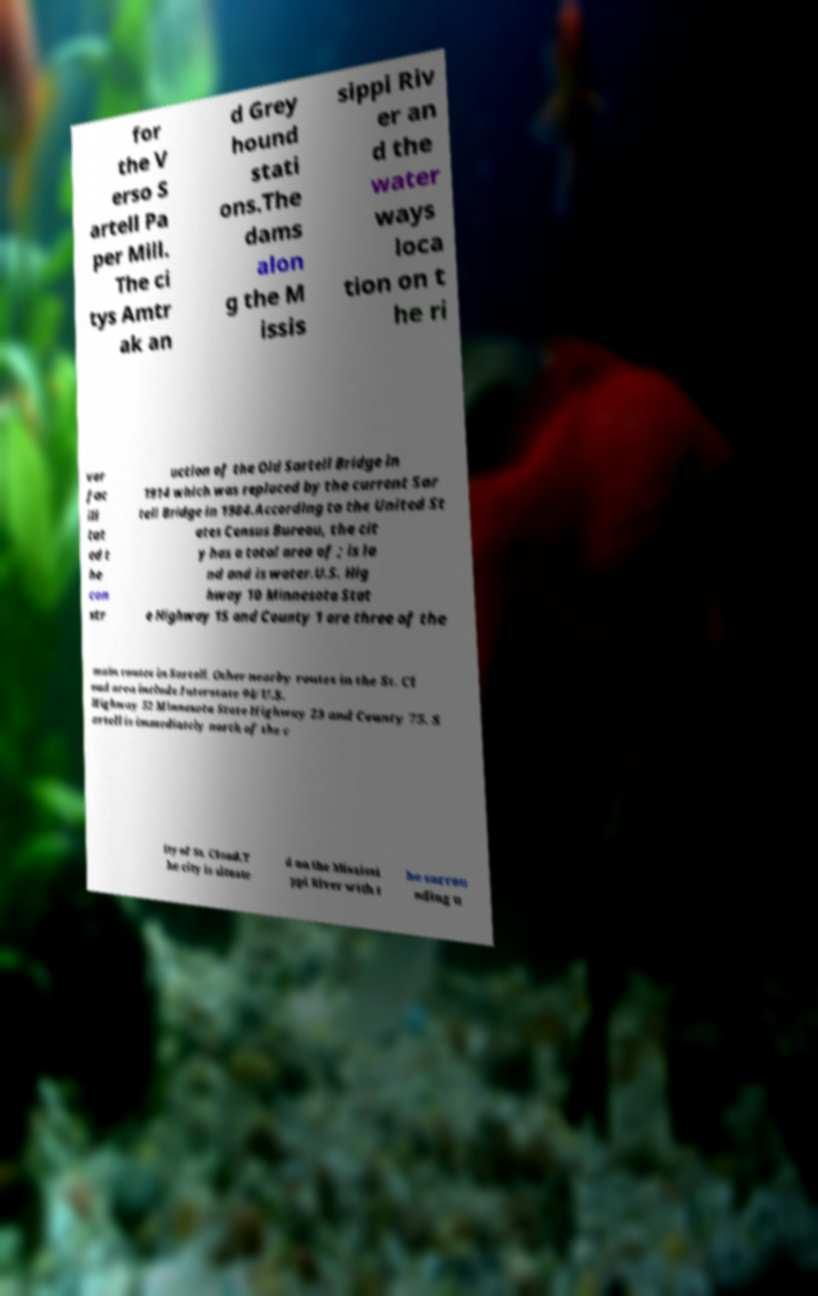Can you read and provide the text displayed in the image?This photo seems to have some interesting text. Can you extract and type it out for me? for the V erso S artell Pa per Mill. The ci tys Amtr ak an d Grey hound stati ons.The dams alon g the M issis sippi Riv er an d the water ways loca tion on t he ri ver fac ili tat ed t he con str uction of the Old Sartell Bridge in 1914 which was replaced by the current Sar tell Bridge in 1984.According to the United St ates Census Bureau, the cit y has a total area of ; is la nd and is water.U.S. Hig hway 10 Minnesota Stat e Highway 15 and County 1 are three of the main routes in Sartell. Other nearby routes in the St. Cl oud area include Interstate 94/U.S. Highway 52 Minnesota State Highway 23 and County 75. S artell is immediately north of the c ity of St. Cloud.T he city is situate d on the Mississi ppi River with t he surrou nding u 